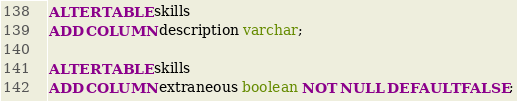<code> <loc_0><loc_0><loc_500><loc_500><_SQL_>ALTER TABLE skills
ADD COLUMN description varchar;

ALTER TABLE skills
ADD COLUMN extraneous boolean NOT NULL DEFAULT FALSE;

</code> 